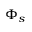Convert formula to latex. <formula><loc_0><loc_0><loc_500><loc_500>\Phi _ { s }</formula> 